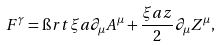Convert formula to latex. <formula><loc_0><loc_0><loc_500><loc_500>F ^ { \gamma } = \i r t { \xi a } \partial _ { \mu } A ^ { \mu } + \frac { \xi a z } { 2 } \partial _ { \mu } Z ^ { \mu } ,</formula> 